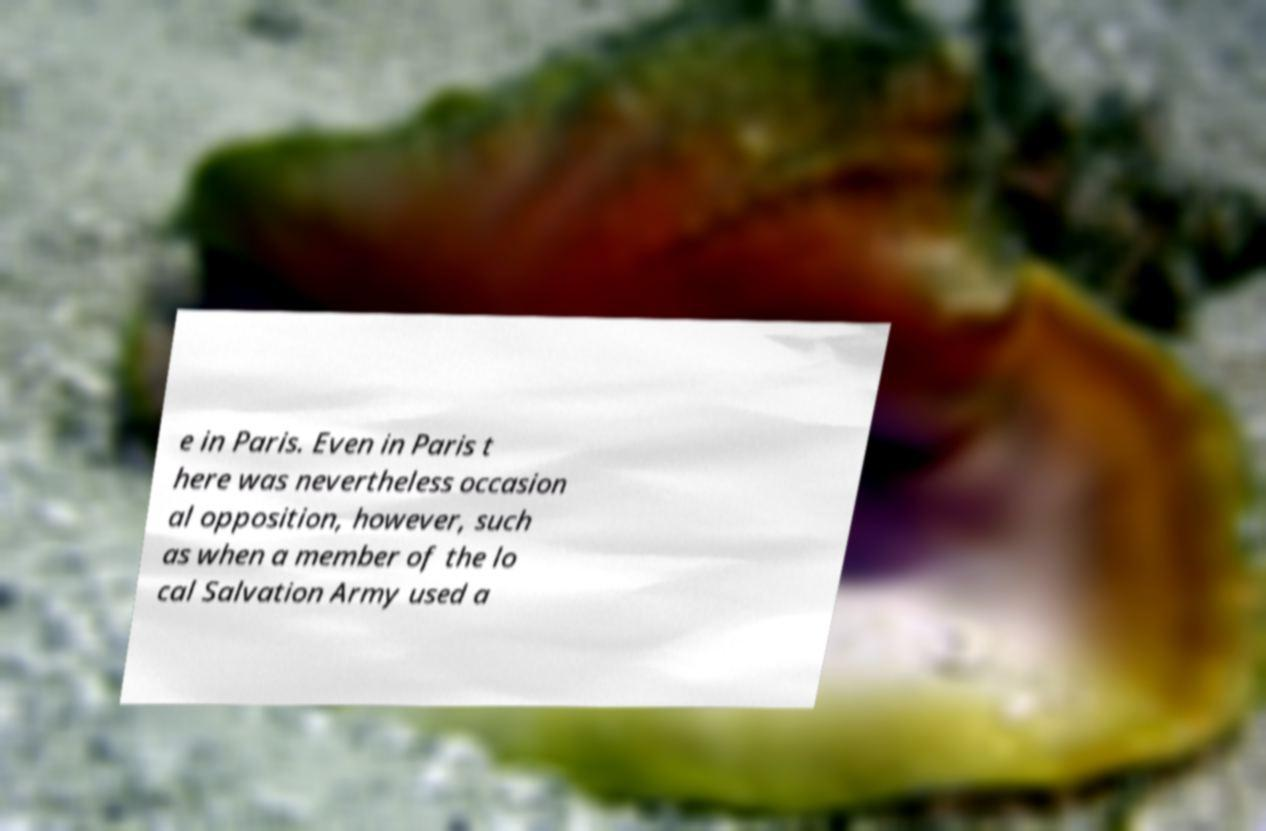I need the written content from this picture converted into text. Can you do that? e in Paris. Even in Paris t here was nevertheless occasion al opposition, however, such as when a member of the lo cal Salvation Army used a 